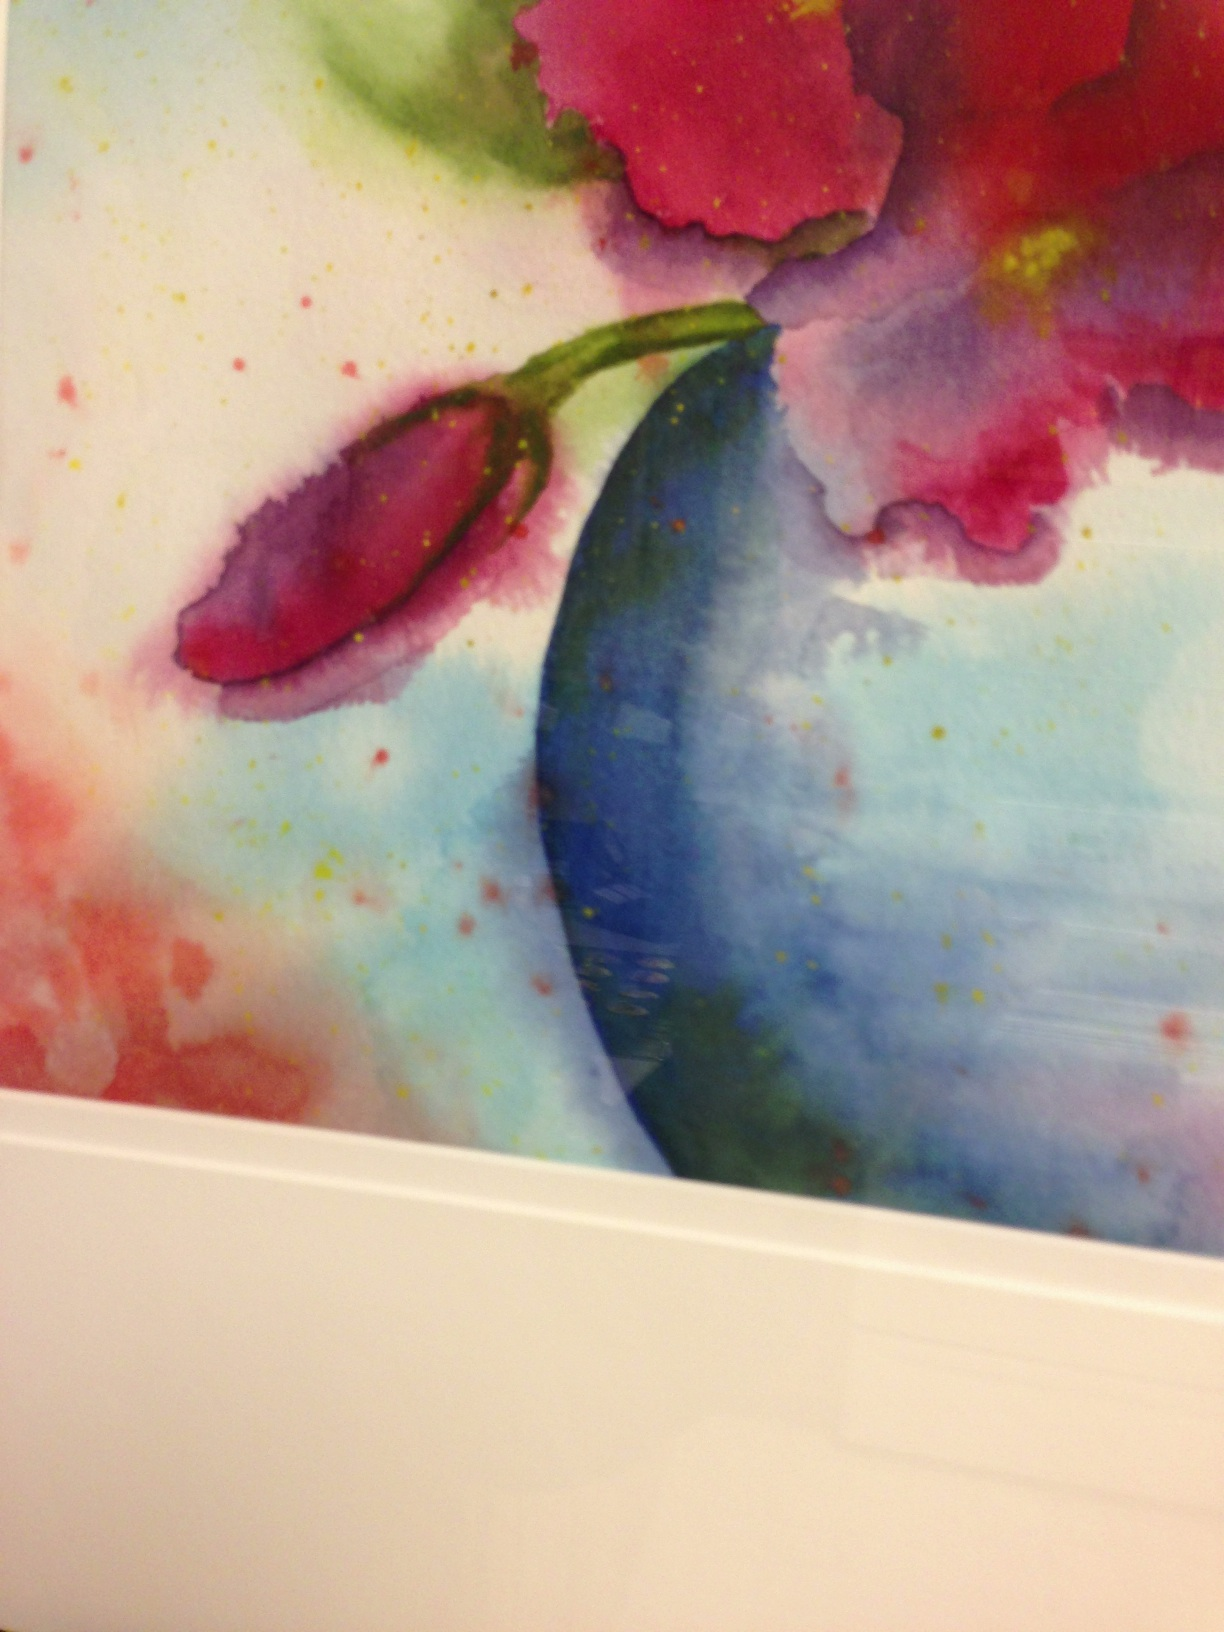What is the object? from Vizwiz The object in the image appears to be a vibrant watercolor painting of a flower bud, likely part of a larger artistic floral composition. The artwork features rich, blended colors that give it a dynamic and fluid appearance. 